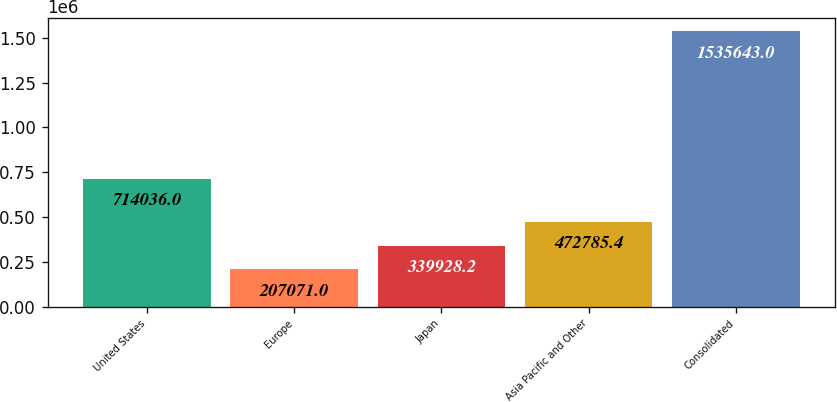<chart> <loc_0><loc_0><loc_500><loc_500><bar_chart><fcel>United States<fcel>Europe<fcel>Japan<fcel>Asia Pacific and Other<fcel>Consolidated<nl><fcel>714036<fcel>207071<fcel>339928<fcel>472785<fcel>1.53564e+06<nl></chart> 